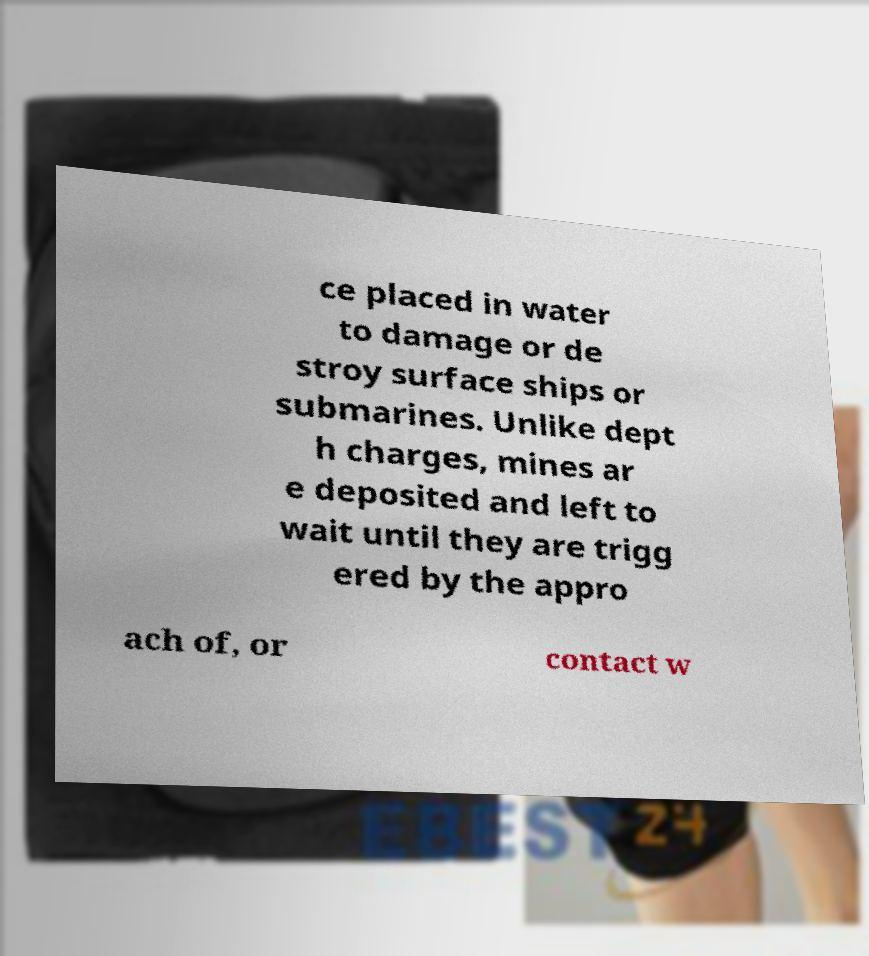Please read and relay the text visible in this image. What does it say? ce placed in water to damage or de stroy surface ships or submarines. Unlike dept h charges, mines ar e deposited and left to wait until they are trigg ered by the appro ach of, or contact w 